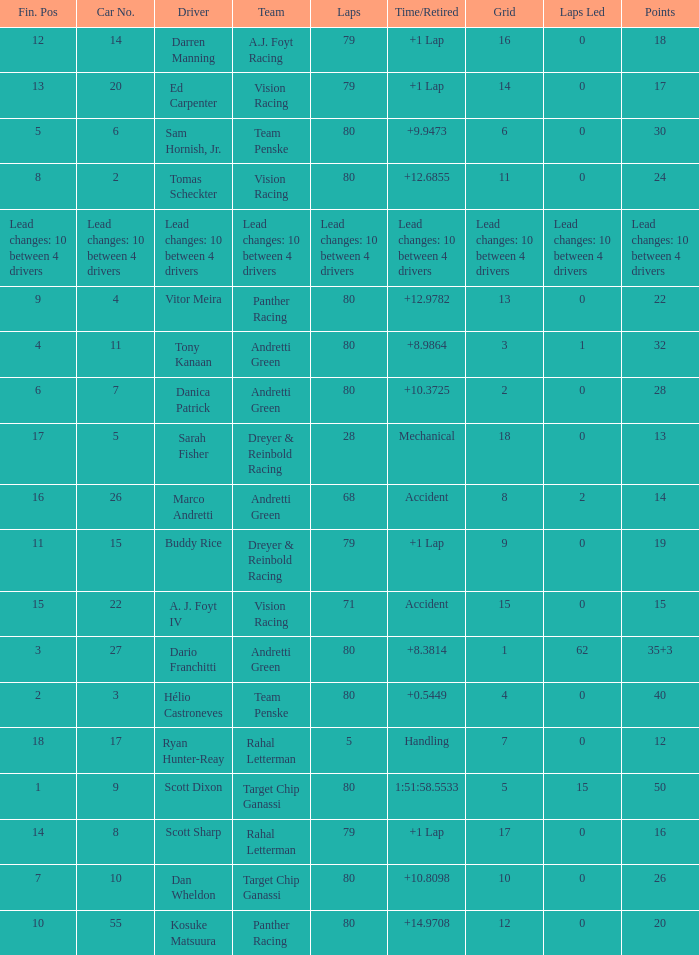What is the total number of points accumulated by driver kosuke matsuura? 20.0. 